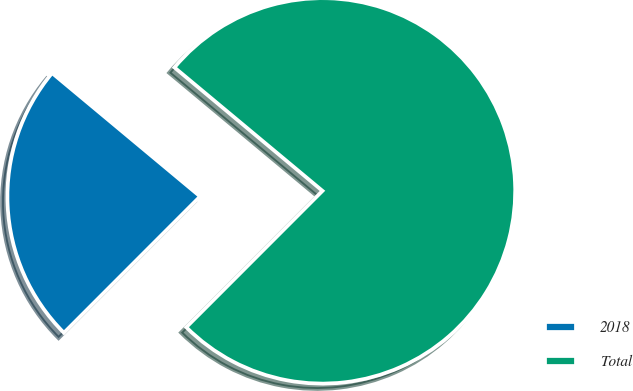Convert chart to OTSL. <chart><loc_0><loc_0><loc_500><loc_500><pie_chart><fcel>2018<fcel>Total<nl><fcel>23.57%<fcel>76.43%<nl></chart> 